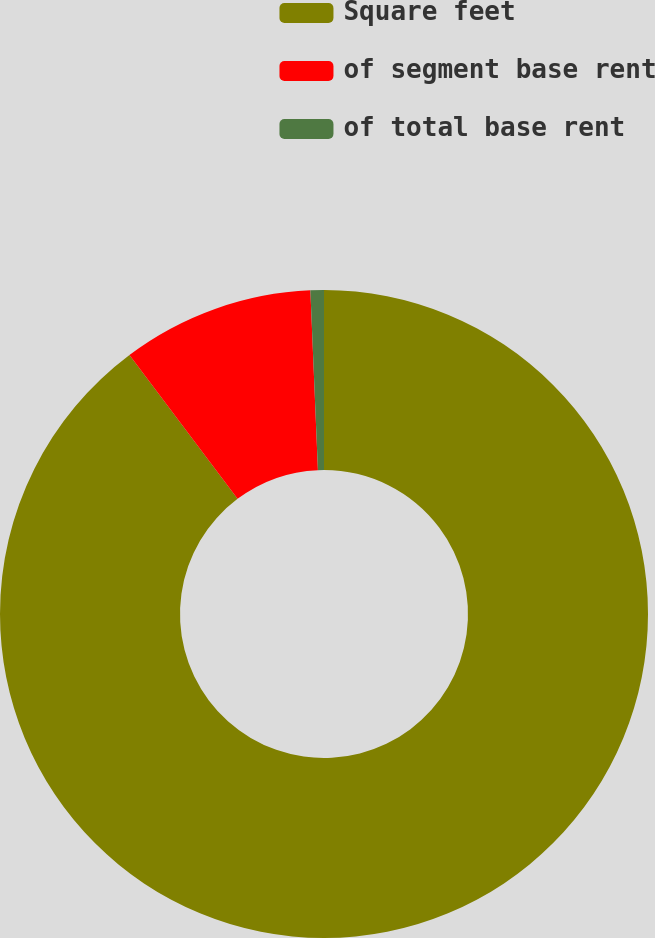Convert chart. <chart><loc_0><loc_0><loc_500><loc_500><pie_chart><fcel>Square feet<fcel>of segment base rent<fcel>of total base rent<nl><fcel>89.75%<fcel>9.58%<fcel>0.67%<nl></chart> 